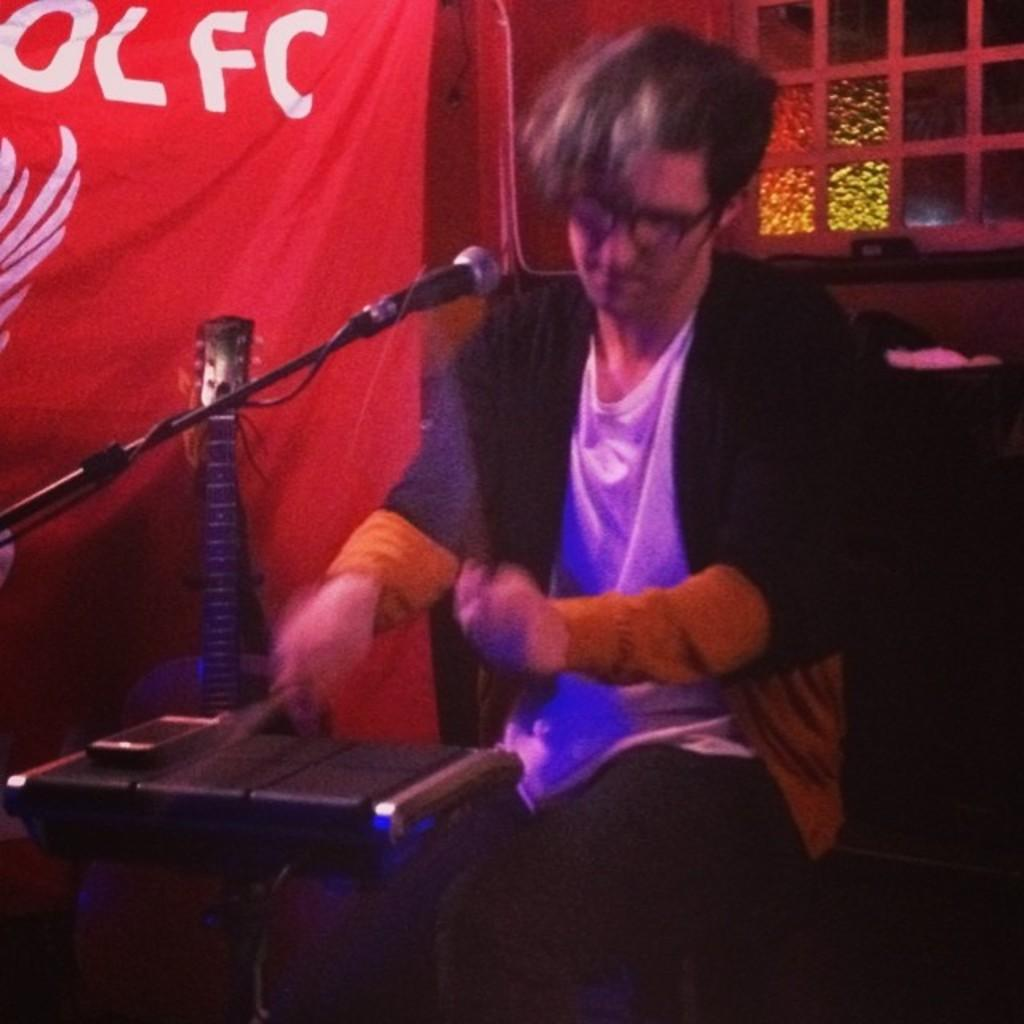What is the main activity being performed in the image? There is a person playing drums in the image. What other musical instrument can be seen in the image? There is a guitar towards the left side of the image. What might be used for amplifying the person's voice in the image? There is a microphone in the image. What can be seen in the background of the image? There is a curtain and a window in the background of the image. What type of linen is being used to cover the drums in the image? There is no linen visible in the image; the drums are not covered. Can you tell me how the person's anger is being expressed through their music in the image? There is no indication of the person's emotions in the image, so it cannot be determined if they are expressing anger through their music. 